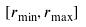Convert formula to latex. <formula><loc_0><loc_0><loc_500><loc_500>[ r _ { \min } , r _ { \max } ]</formula> 